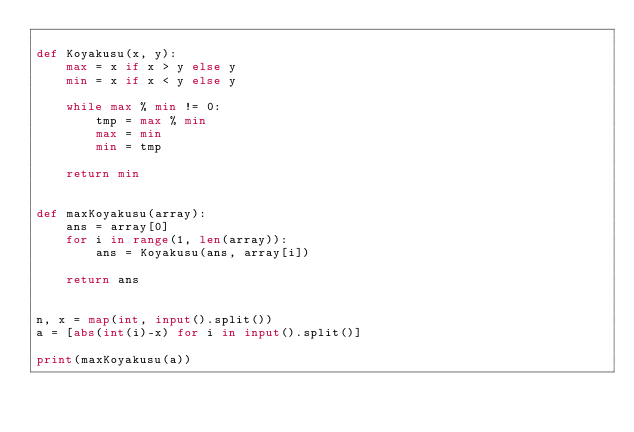Convert code to text. <code><loc_0><loc_0><loc_500><loc_500><_Python_>
def Koyakusu(x, y):
    max = x if x > y else y
    min = x if x < y else y

    while max % min != 0:
        tmp = max % min
        max = min
        min = tmp
    
    return min


def maxKoyakusu(array):
    ans = array[0]
    for i in range(1, len(array)):
        ans = Koyakusu(ans, array[i])

    return ans


n, x = map(int, input().split())
a = [abs(int(i)-x) for i in input().split()]

print(maxKoyakusu(a))</code> 